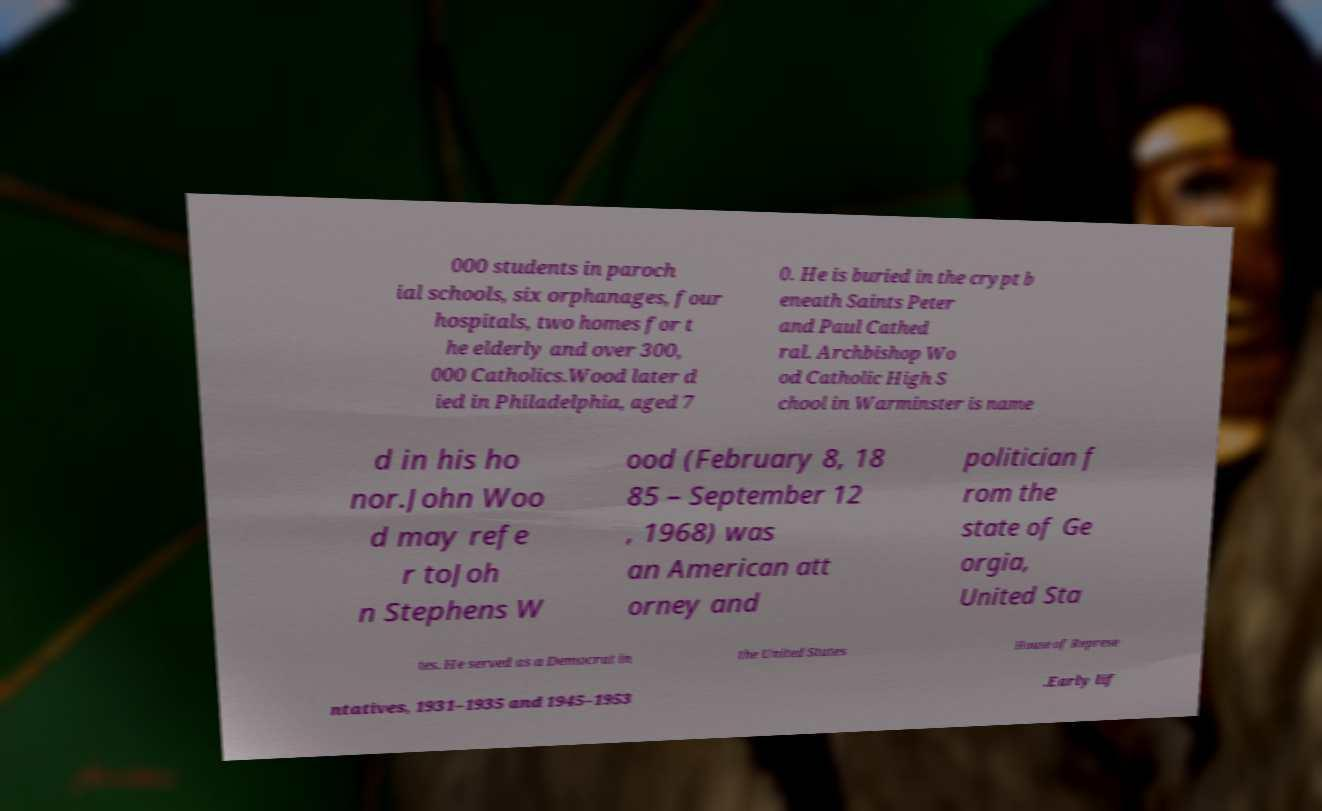For documentation purposes, I need the text within this image transcribed. Could you provide that? 000 students in paroch ial schools, six orphanages, four hospitals, two homes for t he elderly and over 300, 000 Catholics.Wood later d ied in Philadelphia, aged 7 0. He is buried in the crypt b eneath Saints Peter and Paul Cathed ral. Archbishop Wo od Catholic High S chool in Warminster is name d in his ho nor.John Woo d may refe r toJoh n Stephens W ood (February 8, 18 85 – September 12 , 1968) was an American att orney and politician f rom the state of Ge orgia, United Sta tes. He served as a Democrat in the United States House of Represe ntatives, 1931–1935 and 1945–1953 .Early lif 